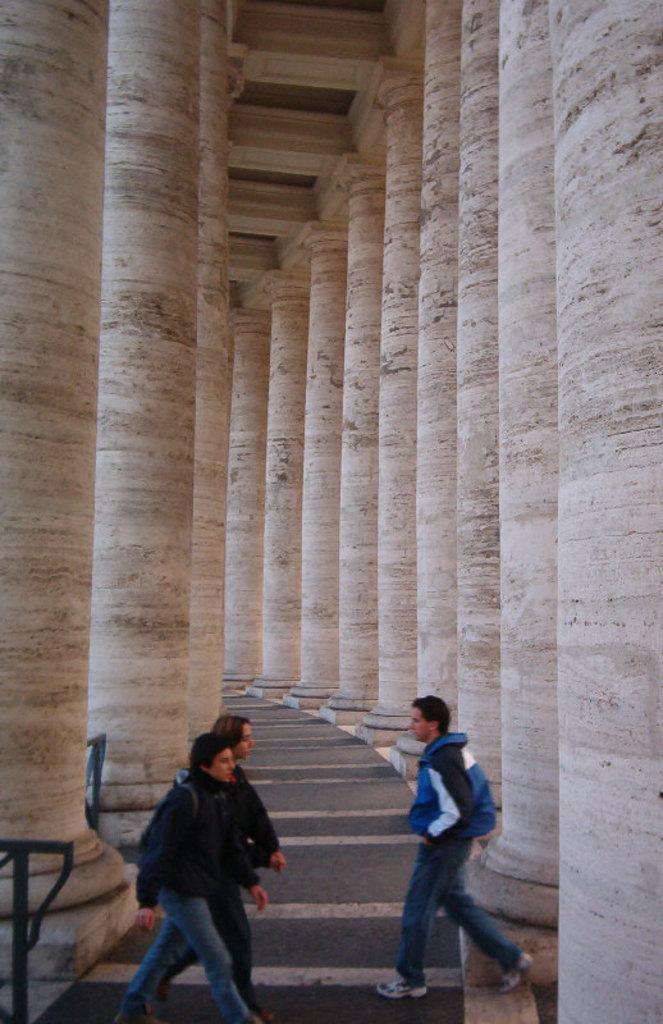How would you summarize this image in a sentence or two? In this picture I can see three persons standing, those are looking like iron rods, and in the background there are pillars. 